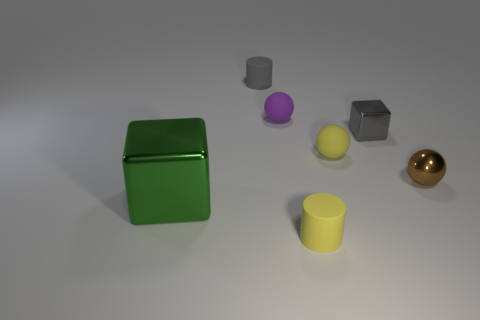Subtract all balls. How many objects are left? 4 Add 1 small yellow balls. How many objects exist? 8 Add 3 small brown metallic spheres. How many small brown metallic spheres are left? 4 Add 2 tiny red cylinders. How many tiny red cylinders exist? 2 Subtract 0 red spheres. How many objects are left? 7 Subtract all shiny balls. Subtract all gray rubber cylinders. How many objects are left? 5 